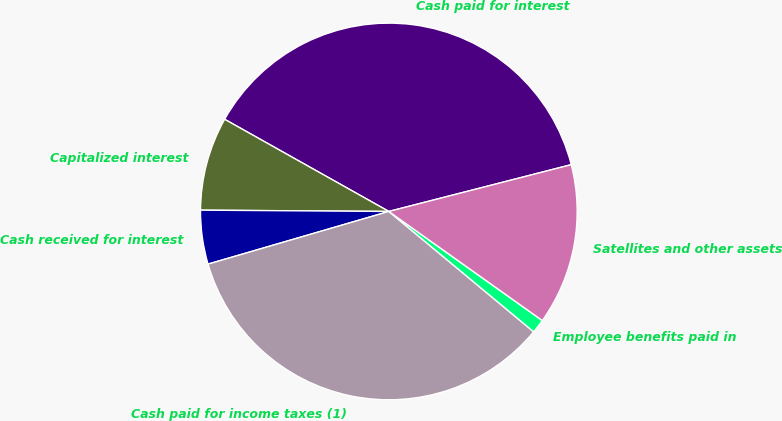Convert chart to OTSL. <chart><loc_0><loc_0><loc_500><loc_500><pie_chart><fcel>Cash paid for interest<fcel>Capitalized interest<fcel>Cash received for interest<fcel>Cash paid for income taxes (1)<fcel>Employee benefits paid in<fcel>Satellites and other assets<nl><fcel>37.86%<fcel>8.03%<fcel>4.62%<fcel>34.45%<fcel>1.2%<fcel>13.83%<nl></chart> 